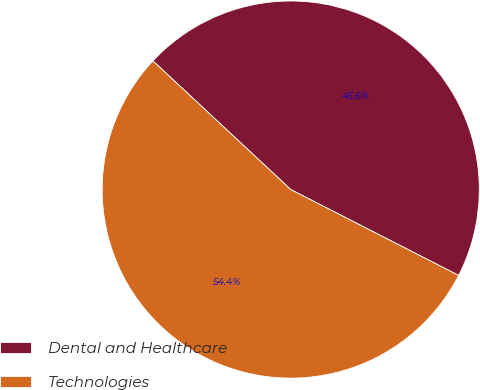<chart> <loc_0><loc_0><loc_500><loc_500><pie_chart><fcel>Dental and Healthcare<fcel>Technologies<nl><fcel>45.57%<fcel>54.43%<nl></chart> 